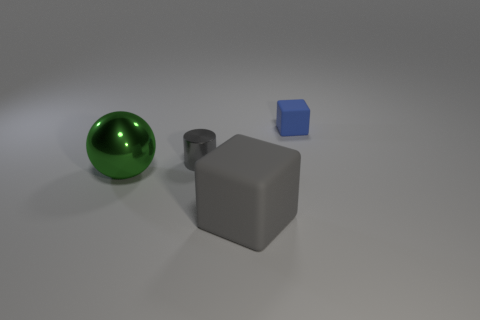Does the big gray block have the same material as the small blue object?
Your answer should be compact. Yes. How many cylinders are either gray matte objects or small blue matte objects?
Your answer should be very brief. 0. What color is the rubber thing to the left of the small matte block?
Give a very brief answer. Gray. How many shiny things are purple balls or large green spheres?
Your answer should be very brief. 1. There is a object right of the large object that is on the right side of the metal cylinder; what is its material?
Keep it short and to the point. Rubber. There is a cylinder that is the same color as the big cube; what is it made of?
Provide a short and direct response. Metal. The tiny matte object has what color?
Keep it short and to the point. Blue. Is there a tiny blue rubber object in front of the small metal cylinder that is on the left side of the big matte cube?
Your response must be concise. No. What material is the blue block?
Your answer should be very brief. Rubber. Is the material of the cube to the left of the blue thing the same as the gray object that is behind the big green sphere?
Give a very brief answer. No. 